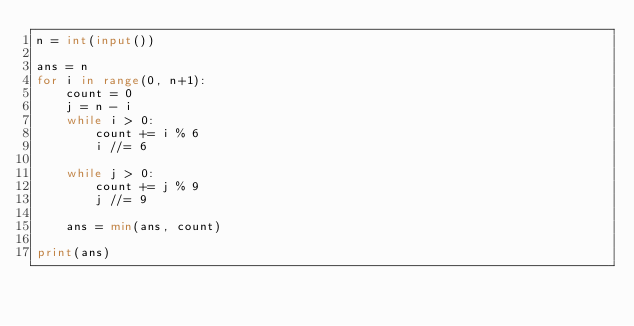Convert code to text. <code><loc_0><loc_0><loc_500><loc_500><_Python_>n = int(input())

ans = n
for i in range(0, n+1):
    count = 0
    j = n - i
    while i > 0:
        count += i % 6
        i //= 6
    
    while j > 0:
        count += j % 9
        j //= 9
        
    ans = min(ans, count)

print(ans)</code> 